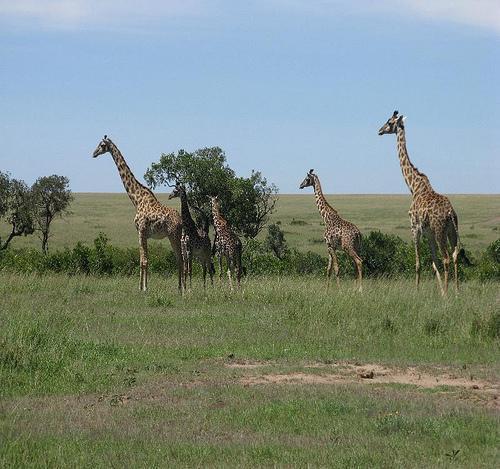How many giraffes are shown?
Give a very brief answer. 5. How many elephants are pictured?
Give a very brief answer. 0. How many giraffes are there?
Give a very brief answer. 3. 